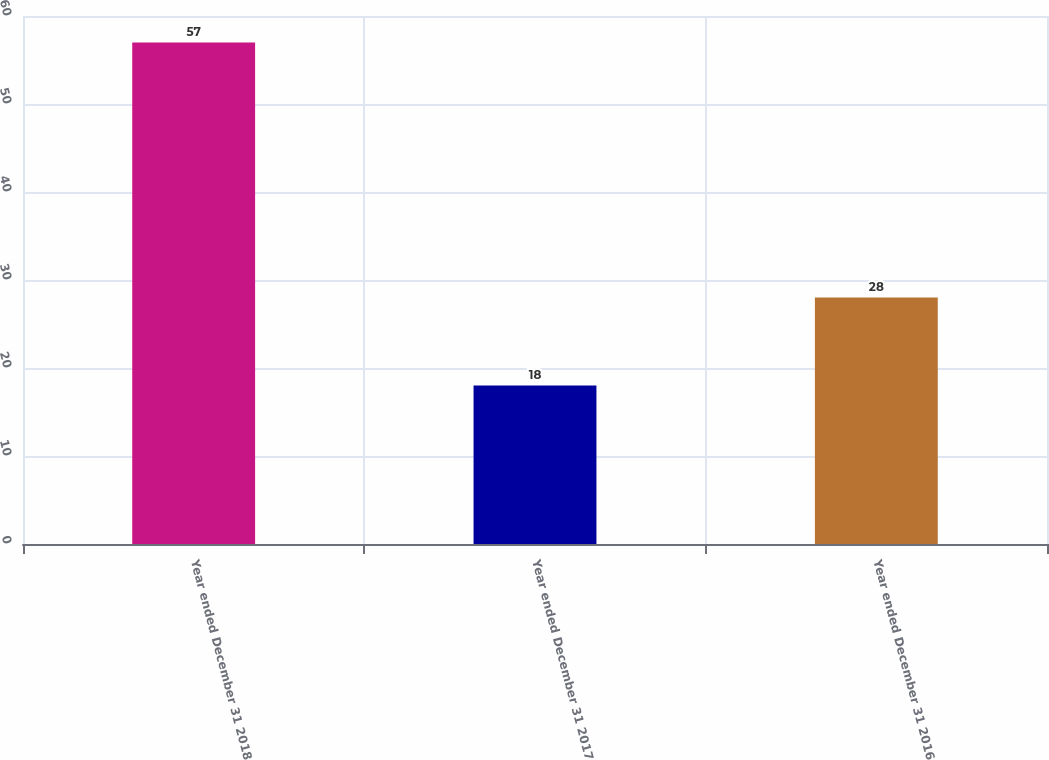Convert chart to OTSL. <chart><loc_0><loc_0><loc_500><loc_500><bar_chart><fcel>Year ended December 31 2018<fcel>Year ended December 31 2017<fcel>Year ended December 31 2016<nl><fcel>57<fcel>18<fcel>28<nl></chart> 